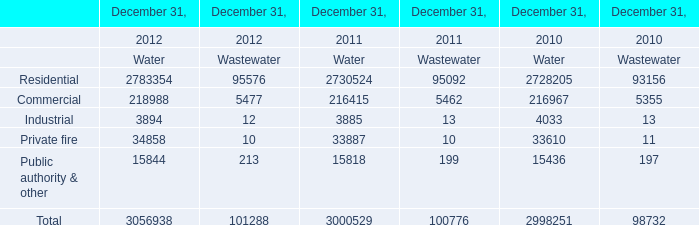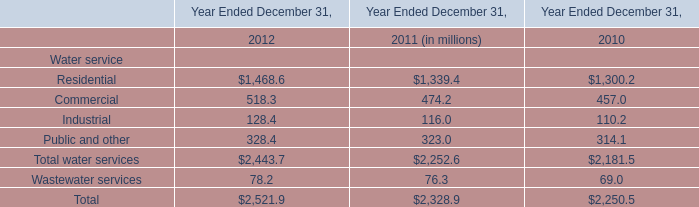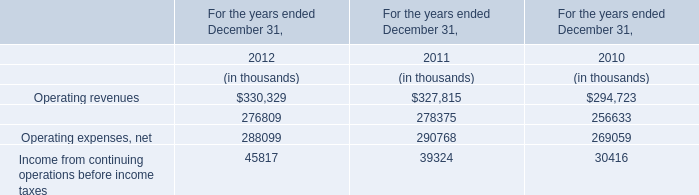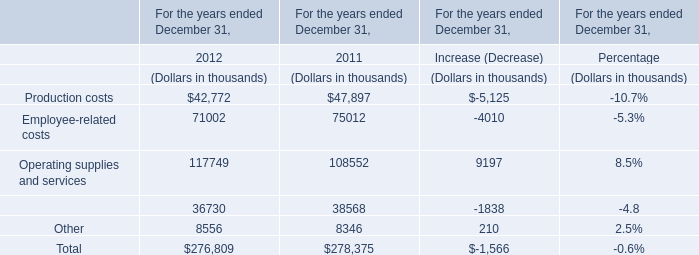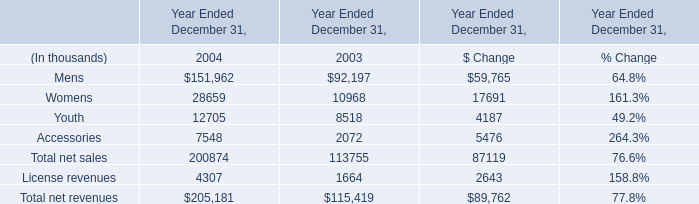What's the average of Operating revenues and Operation and maintenance expense in 2012? (in thousand) 
Computations: ((330329 + 276809) / 2)
Answer: 303569.0. 